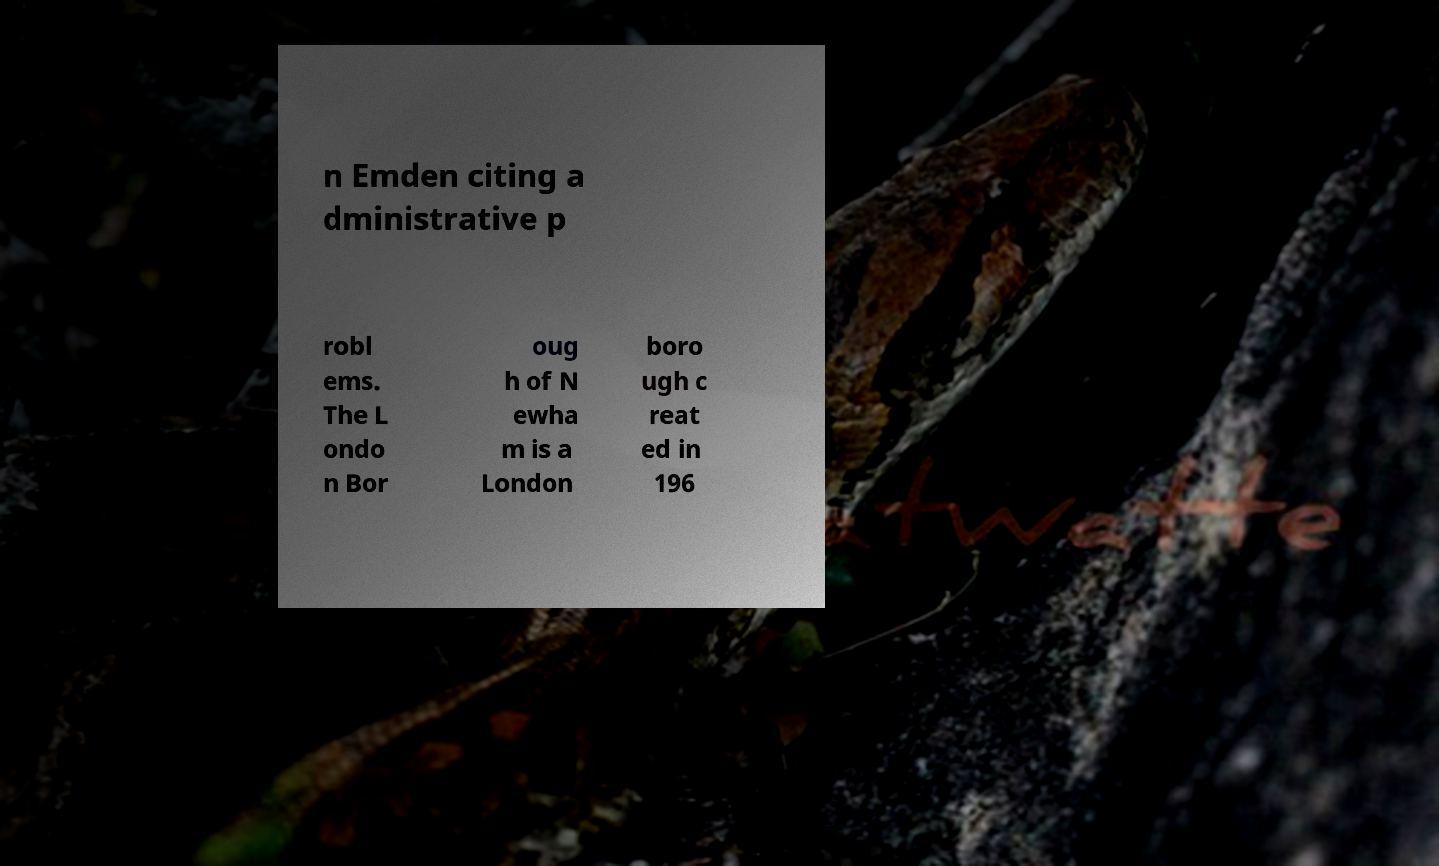For documentation purposes, I need the text within this image transcribed. Could you provide that? n Emden citing a dministrative p robl ems. The L ondo n Bor oug h of N ewha m is a London boro ugh c reat ed in 196 